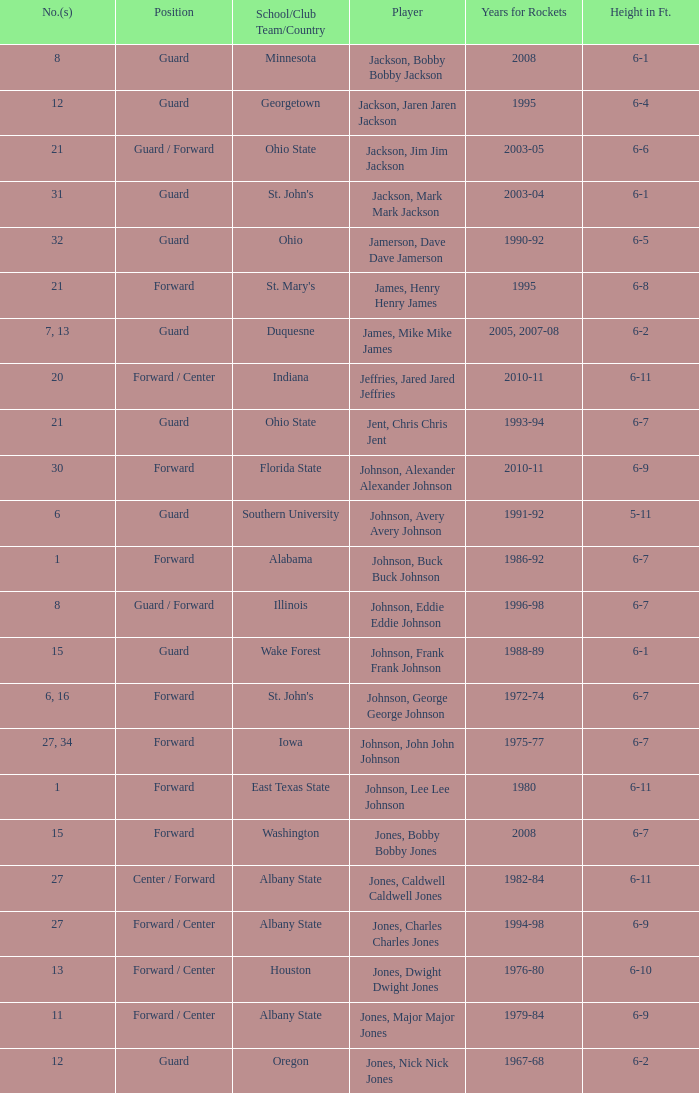Which player who played for the Rockets for the years 1986-92? Johnson, Buck Buck Johnson. 